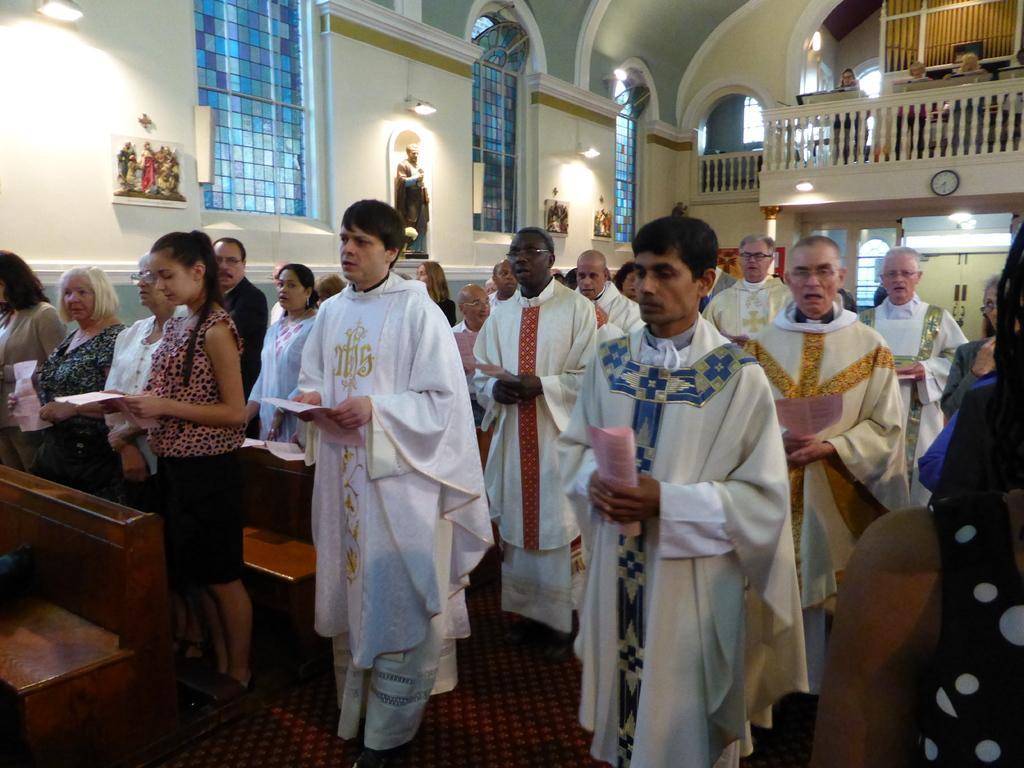Could you give a brief overview of what you see in this image? In this image I can see the group of people with different color dresses and these people are holding the papers. I can see the benches. In the background I can see the statues, lights and the windows to the wall. I can see few people are in-front of the railing. 